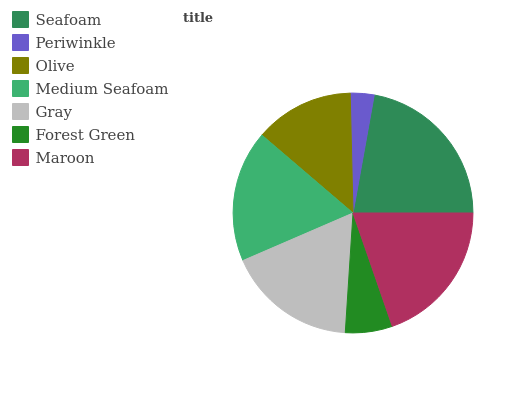Is Periwinkle the minimum?
Answer yes or no. Yes. Is Seafoam the maximum?
Answer yes or no. Yes. Is Olive the minimum?
Answer yes or no. No. Is Olive the maximum?
Answer yes or no. No. Is Olive greater than Periwinkle?
Answer yes or no. Yes. Is Periwinkle less than Olive?
Answer yes or no. Yes. Is Periwinkle greater than Olive?
Answer yes or no. No. Is Olive less than Periwinkle?
Answer yes or no. No. Is Gray the high median?
Answer yes or no. Yes. Is Gray the low median?
Answer yes or no. Yes. Is Maroon the high median?
Answer yes or no. No. Is Seafoam the low median?
Answer yes or no. No. 